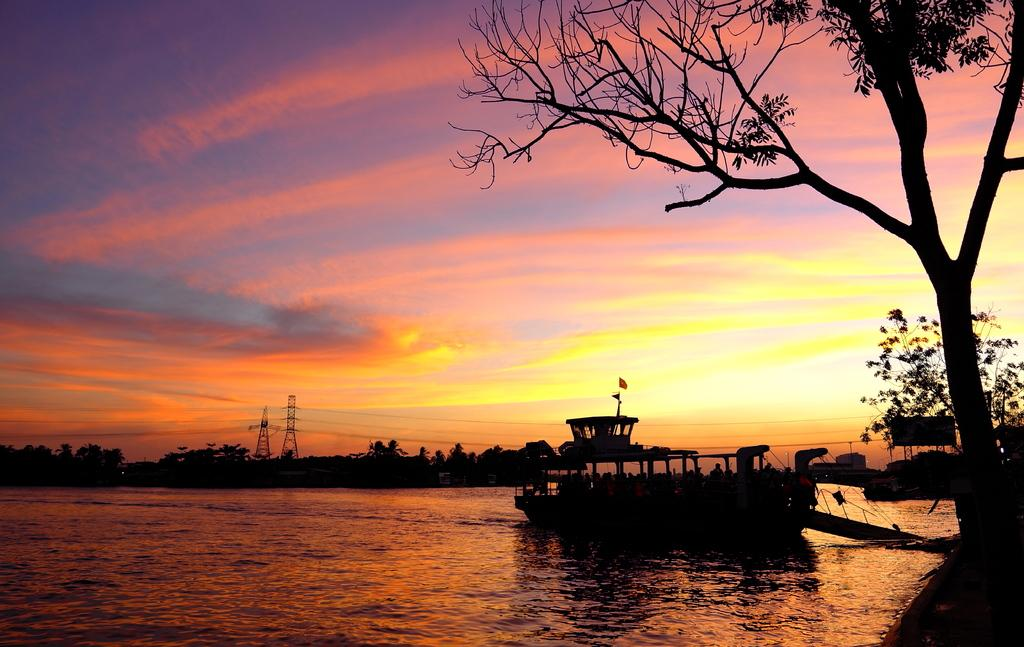What is the main subject of the image? The main subject of the image is a ship. Where is the ship located in the image? The ship is on a river in the image. What can be seen in the background of the image? There are trees, towers, and wires visible in the background of the image. What is visible at the top of the image? The sky is visible at the top of the image. What type of zephyr can be seen blowing through the ship's sails in the image? There is no zephyr present in the image, and the ship's sails are not visible. What type of school is depicted in the image? There is no school present in the image; it features a ship on a river. 